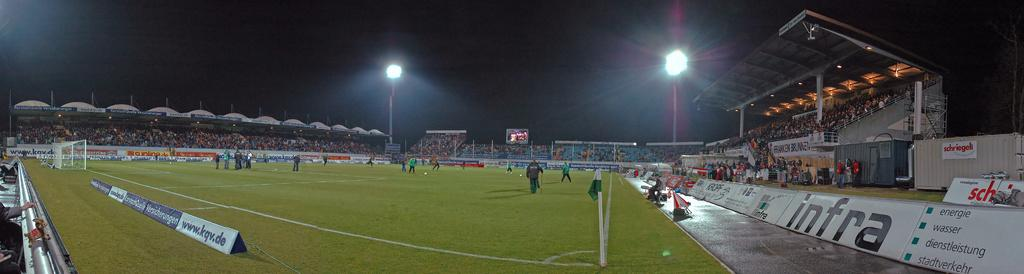<image>
Summarize the visual content of the image. A stadium with advertising for infra and www.kqv.de. 